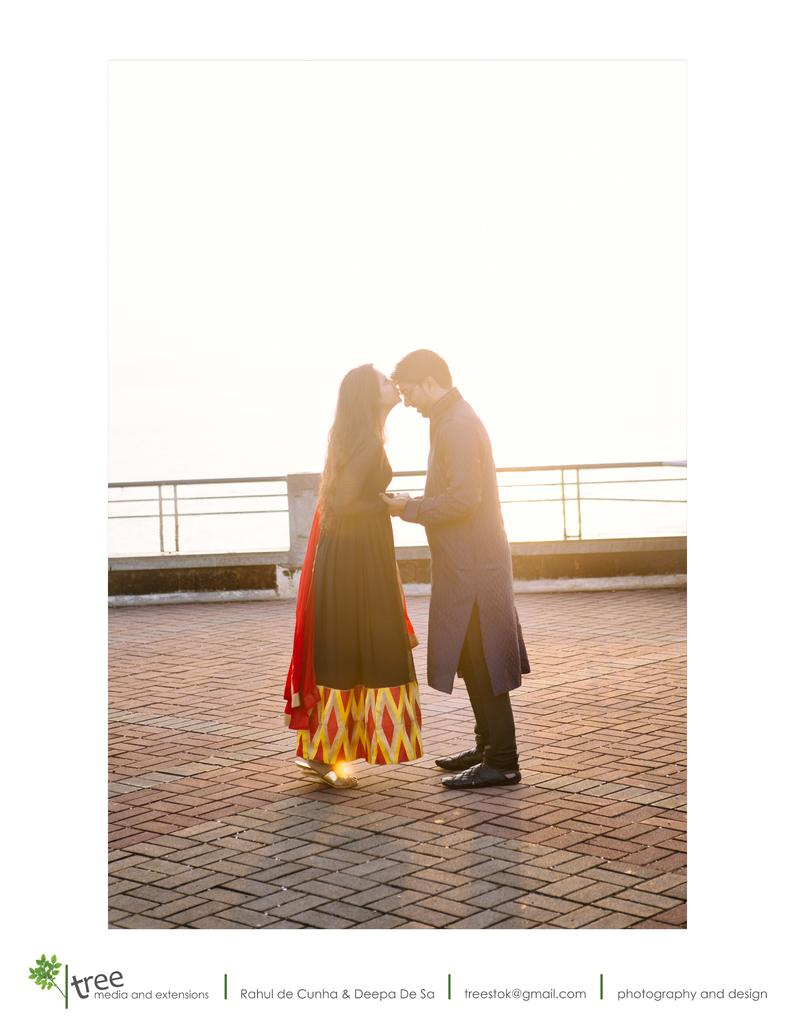Who are the people in the image? There is a man and a woman in the image. What are the man and woman doing in the image? They are standing on land. What is located beside the man and woman? There is a fence beside them. What can be seen above the man and woman in the image? The sky is visible above them. What type of zinc is being used to build the fence in the image? There is no mention of zinc or any building materials in the image; it only shows a fence beside the man and woman. Can you tell me the story behind the pig in the image? There is no pig present in the image; it only features a man, a woman, a fence, and the sky. 